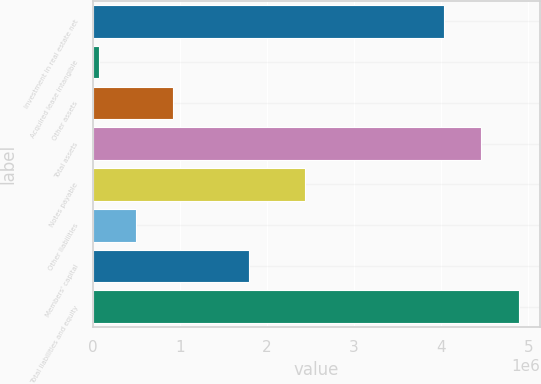Convert chart to OTSL. <chart><loc_0><loc_0><loc_500><loc_500><bar_chart><fcel>Investment in real estate net<fcel>Acquired lease intangible<fcel>Other assets<fcel>Total assets<fcel>Notes payable<fcel>Other liabilities<fcel>Members' capital<fcel>Total liabilities and equity<nl><fcel>4.02939e+06<fcel>69336<fcel>928604<fcel>4.45902e+06<fcel>2.43523e+06<fcel>498970<fcel>1.79082e+06<fcel>4.88866e+06<nl></chart> 